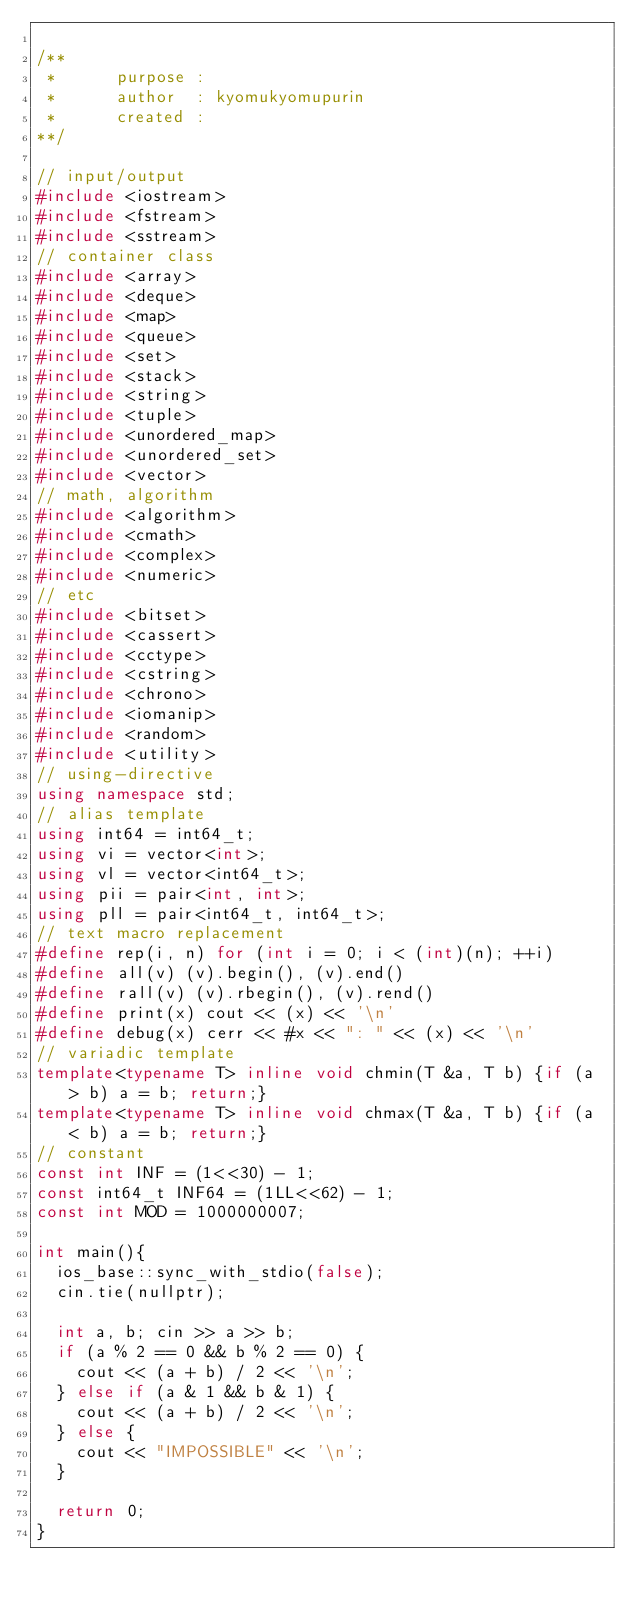Convert code to text. <code><loc_0><loc_0><loc_500><loc_500><_C++_>
/**
 *      purpose : 
 *      author  : kyomukyomupurin
 *      created : 
**/

// input/output
#include <iostream>
#include <fstream>
#include <sstream>
// container class
#include <array>
#include <deque>
#include <map>
#include <queue>
#include <set>
#include <stack>
#include <string>
#include <tuple>
#include <unordered_map>
#include <unordered_set>
#include <vector>
// math, algorithm
#include <algorithm>
#include <cmath>
#include <complex>
#include <numeric>
// etc
#include <bitset>
#include <cassert>
#include <cctype>
#include <cstring>
#include <chrono>
#include <iomanip>
#include <random>
#include <utility>
// using-directive
using namespace std;
// alias template
using int64 = int64_t;
using vi = vector<int>;
using vl = vector<int64_t>;
using pii = pair<int, int>;
using pll = pair<int64_t, int64_t>;
// text macro replacement
#define rep(i, n) for (int i = 0; i < (int)(n); ++i)
#define all(v) (v).begin(), (v).end()
#define rall(v) (v).rbegin(), (v).rend()
#define print(x) cout << (x) << '\n'
#define debug(x) cerr << #x << ": " << (x) << '\n'
// variadic template
template<typename T> inline void chmin(T &a, T b) {if (a > b) a = b; return;}
template<typename T> inline void chmax(T &a, T b) {if (a < b) a = b; return;}
// constant
const int INF = (1<<30) - 1;
const int64_t INF64 = (1LL<<62) - 1;
const int MOD = 1000000007;

int main(){
  ios_base::sync_with_stdio(false);
  cin.tie(nullptr);

  int a, b; cin >> a >> b;
  if (a % 2 == 0 && b % 2 == 0) {
    cout << (a + b) / 2 << '\n';
  } else if (a & 1 && b & 1) {
    cout << (a + b) / 2 << '\n';
  } else {
    cout << "IMPOSSIBLE" << '\n';
  }

  return 0;
}</code> 